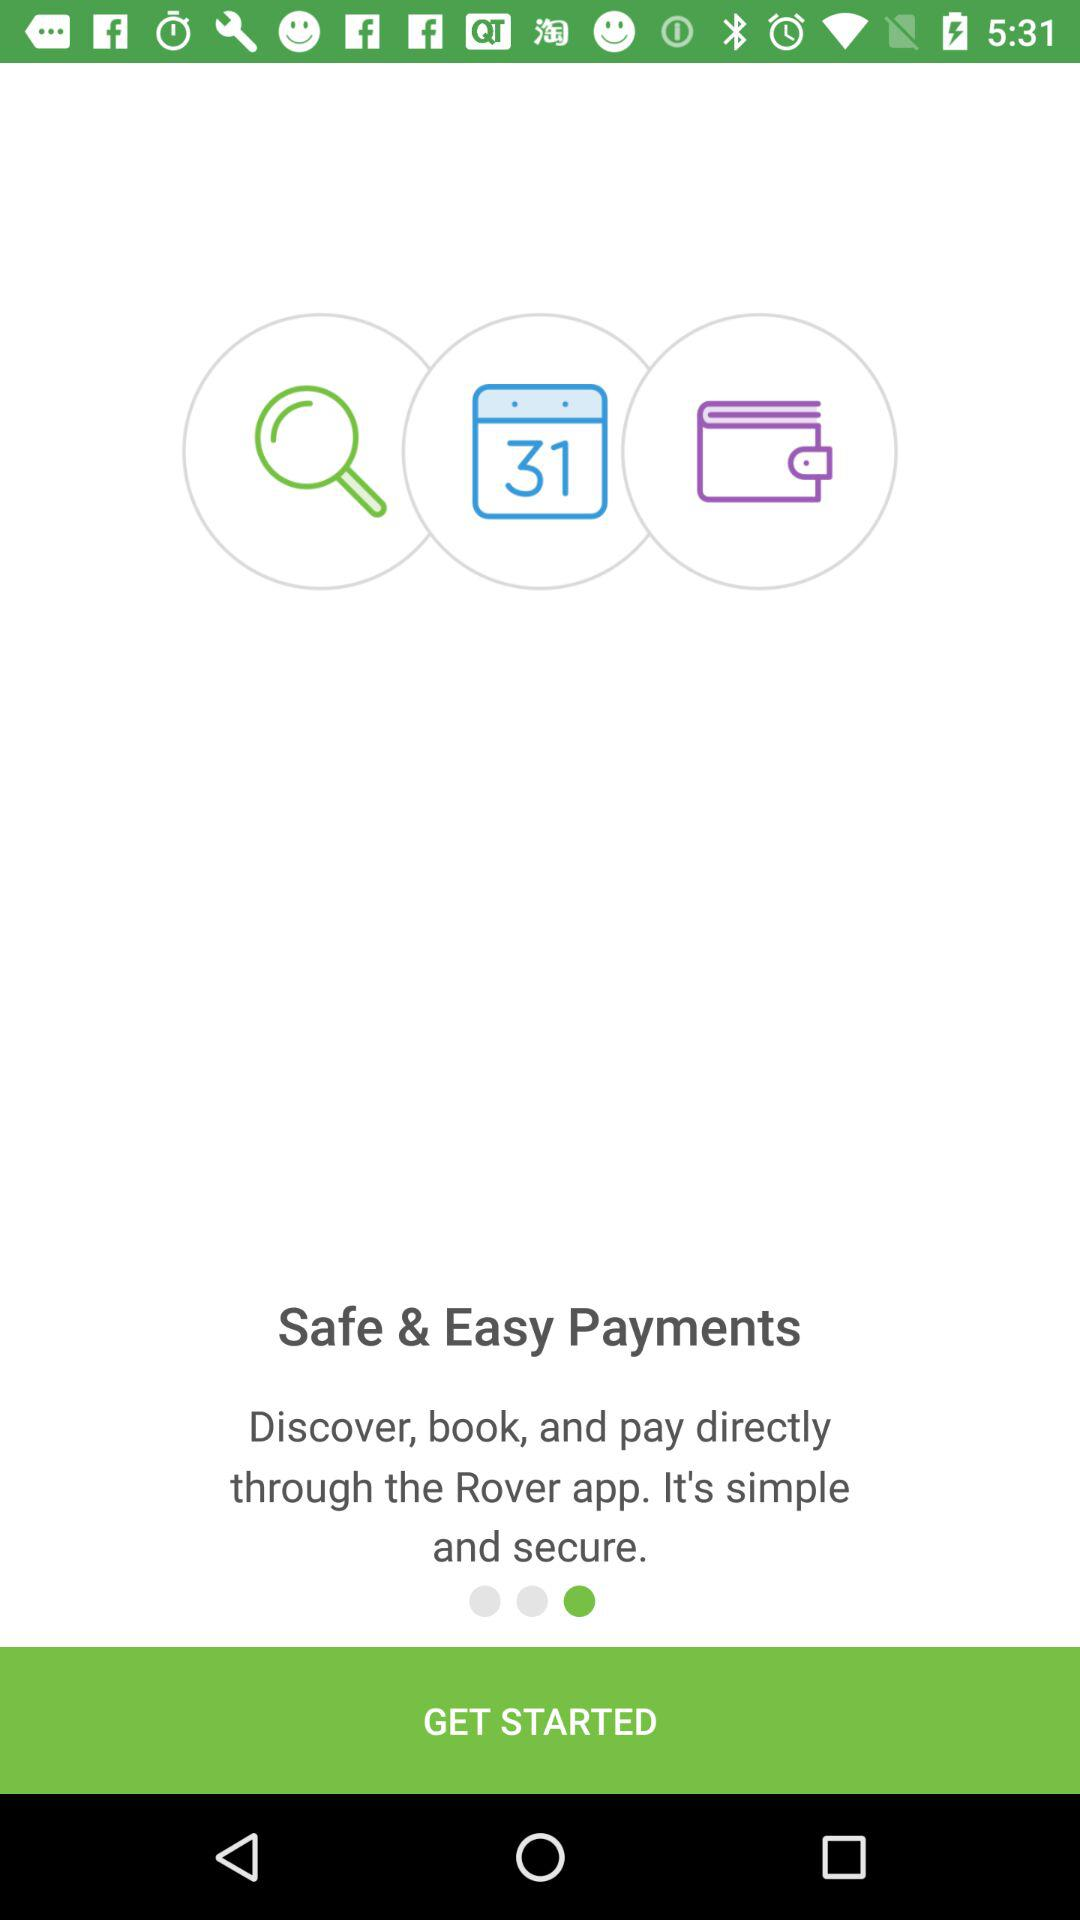What is the application name? The application name is "Rover". 